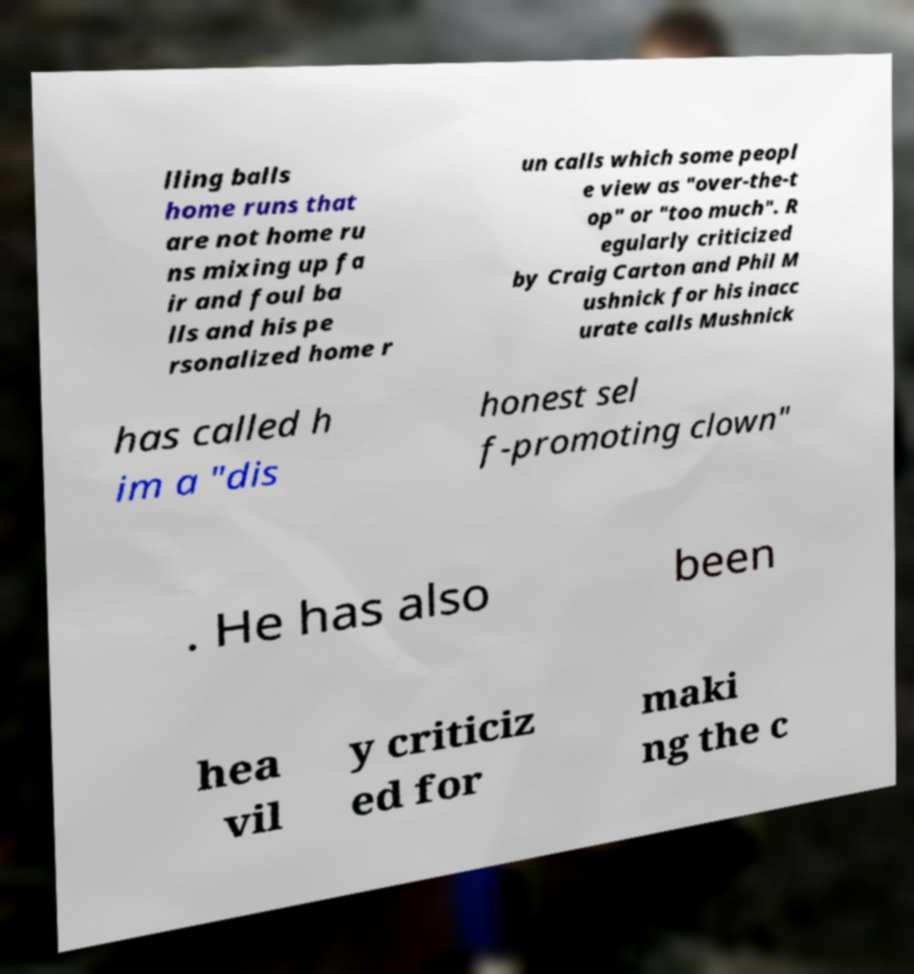Please identify and transcribe the text found in this image. lling balls home runs that are not home ru ns mixing up fa ir and foul ba lls and his pe rsonalized home r un calls which some peopl e view as "over-the-t op" or "too much". R egularly criticized by Craig Carton and Phil M ushnick for his inacc urate calls Mushnick has called h im a "dis honest sel f-promoting clown" . He has also been hea vil y criticiz ed for maki ng the c 